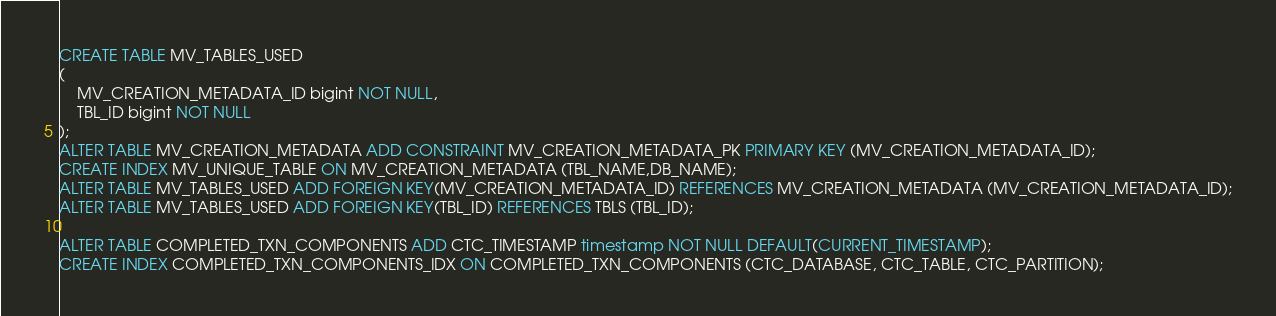<code> <loc_0><loc_0><loc_500><loc_500><_SQL_>CREATE TABLE MV_TABLES_USED
(
    MV_CREATION_METADATA_ID bigint NOT NULL,
    TBL_ID bigint NOT NULL
);
ALTER TABLE MV_CREATION_METADATA ADD CONSTRAINT MV_CREATION_METADATA_PK PRIMARY KEY (MV_CREATION_METADATA_ID);
CREATE INDEX MV_UNIQUE_TABLE ON MV_CREATION_METADATA (TBL_NAME,DB_NAME);
ALTER TABLE MV_TABLES_USED ADD FOREIGN KEY(MV_CREATION_METADATA_ID) REFERENCES MV_CREATION_METADATA (MV_CREATION_METADATA_ID);
ALTER TABLE MV_TABLES_USED ADD FOREIGN KEY(TBL_ID) REFERENCES TBLS (TBL_ID);

ALTER TABLE COMPLETED_TXN_COMPONENTS ADD CTC_TIMESTAMP timestamp NOT NULL DEFAULT(CURRENT_TIMESTAMP);
CREATE INDEX COMPLETED_TXN_COMPONENTS_IDX ON COMPLETED_TXN_COMPONENTS (CTC_DATABASE, CTC_TABLE, CTC_PARTITION);
</code> 